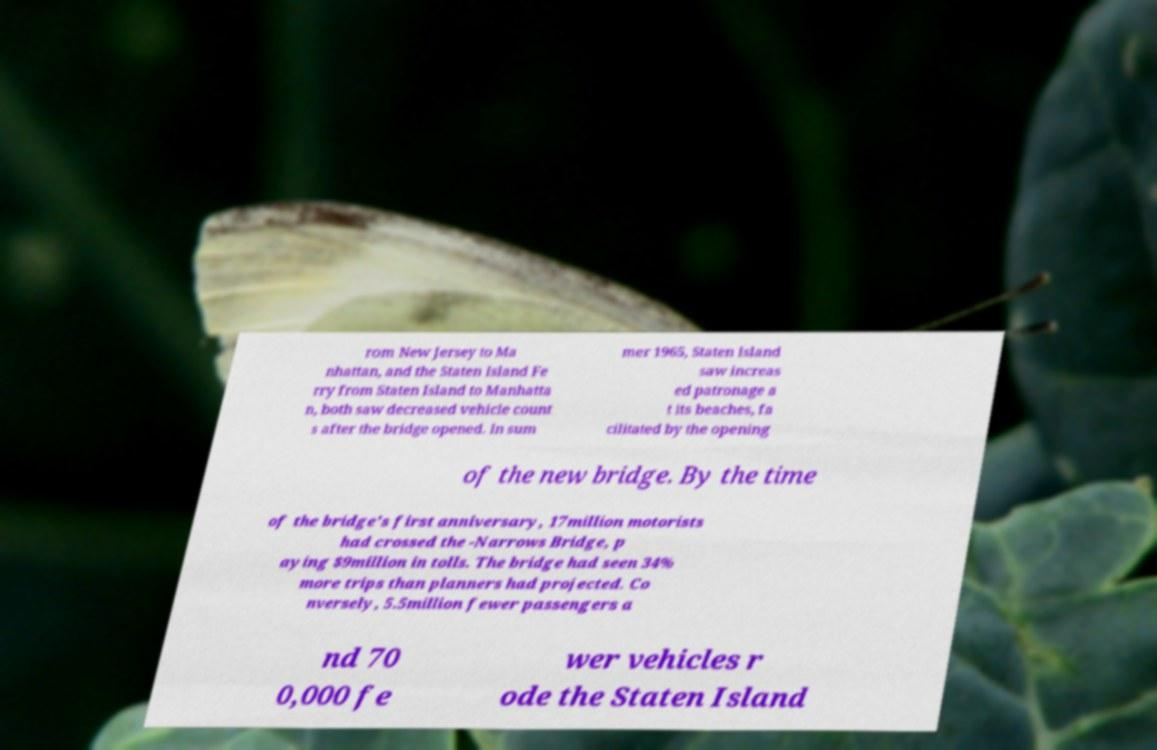There's text embedded in this image that I need extracted. Can you transcribe it verbatim? rom New Jersey to Ma nhattan, and the Staten Island Fe rry from Staten Island to Manhatta n, both saw decreased vehicle count s after the bridge opened. In sum mer 1965, Staten Island saw increas ed patronage a t its beaches, fa cilitated by the opening of the new bridge. By the time of the bridge's first anniversary, 17million motorists had crossed the -Narrows Bridge, p aying $9million in tolls. The bridge had seen 34% more trips than planners had projected. Co nversely, 5.5million fewer passengers a nd 70 0,000 fe wer vehicles r ode the Staten Island 